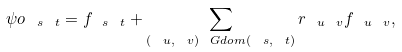Convert formula to latex. <formula><loc_0><loc_0><loc_500><loc_500>\psi o _ { \ s \ t } = f _ { \ s \ t } + \sum _ { ( \ u , \ v ) \ G d o m ( \ s , \ t ) } r _ { \ u \ v } f _ { \ u \ v } ,</formula> 